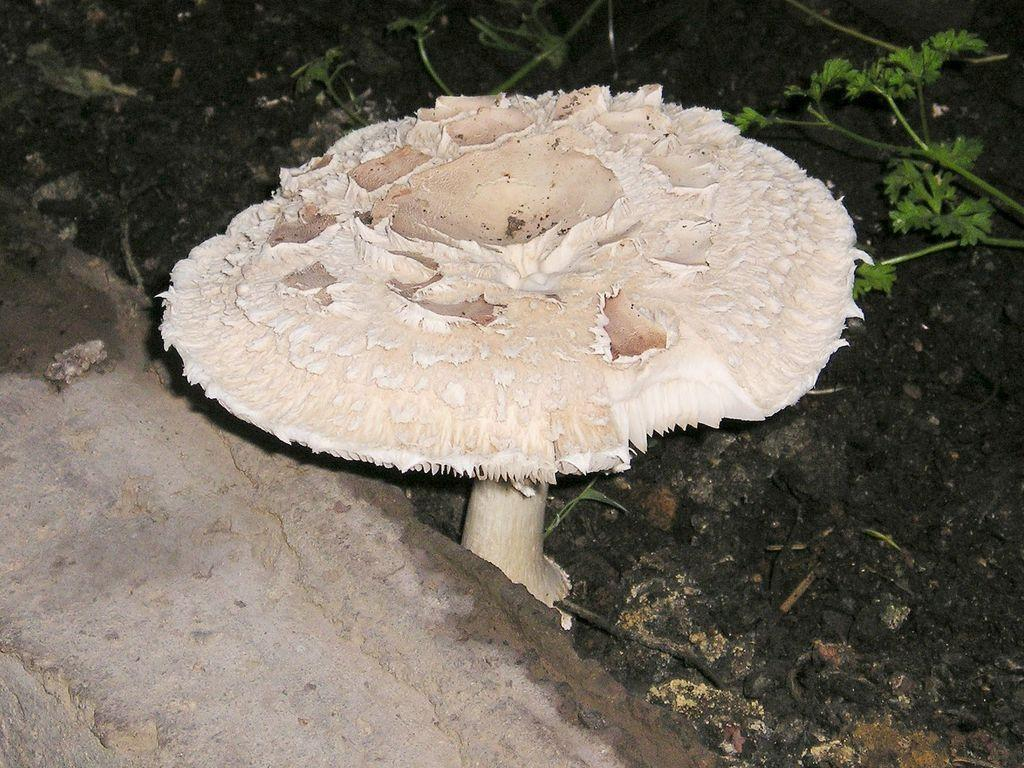What is the main subject in the center of the image? There is a mushroom in the center of the image. Where is the mushroom located? The mushroom is on the ground. What type of attraction is near the mushroom in the image? There is no attraction visible in the image; it only features a mushroom on the ground. How many legs does the mushroom have in the image? Mushrooms do not have legs, so this question cannot be answered based on the image. 